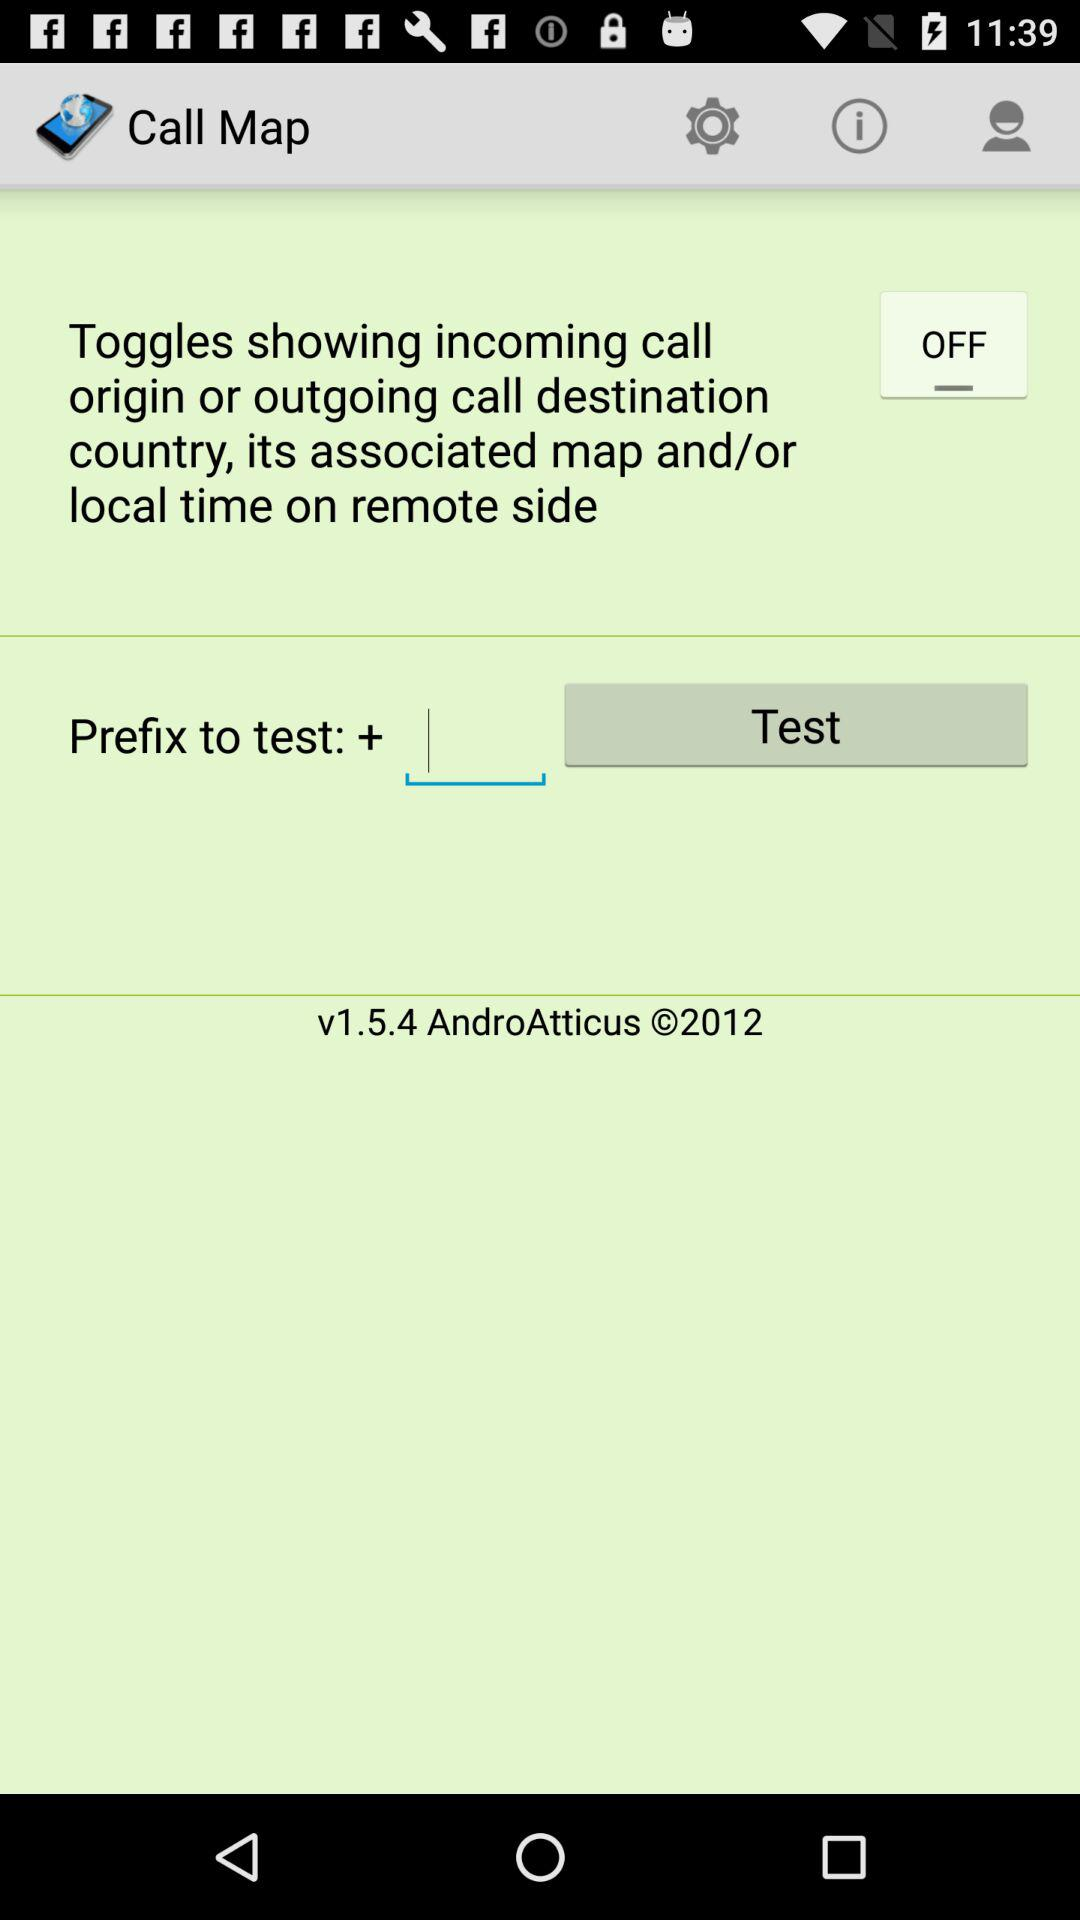What is the version of the application? The version of the application is 1.5.4. 